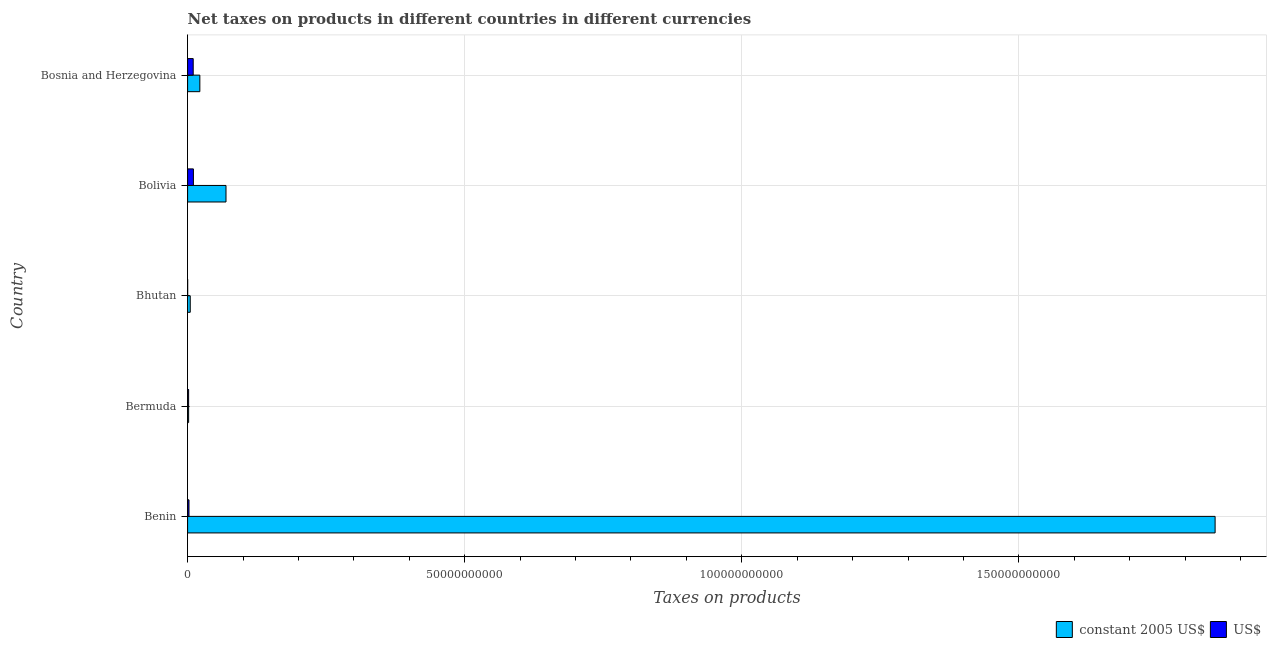Are the number of bars per tick equal to the number of legend labels?
Keep it short and to the point. Yes. Are the number of bars on each tick of the Y-axis equal?
Keep it short and to the point. Yes. How many bars are there on the 1st tick from the top?
Give a very brief answer. 2. What is the label of the 5th group of bars from the top?
Your response must be concise. Benin. In how many cases, is the number of bars for a given country not equal to the number of legend labels?
Keep it short and to the point. 0. What is the net taxes in us$ in Bhutan?
Offer a very short reply. 1.02e+07. Across all countries, what is the maximum net taxes in us$?
Offer a terse response. 1.05e+09. Across all countries, what is the minimum net taxes in constant 2005 us$?
Your answer should be compact. 1.85e+08. In which country was the net taxes in constant 2005 us$ minimum?
Provide a short and direct response. Bermuda. What is the total net taxes in us$ in the graph?
Offer a very short reply. 2.51e+09. What is the difference between the net taxes in constant 2005 us$ in Benin and that in Bhutan?
Make the answer very short. 1.85e+11. What is the difference between the net taxes in us$ in Bhutan and the net taxes in constant 2005 us$ in Bolivia?
Ensure brevity in your answer.  -6.92e+09. What is the average net taxes in us$ per country?
Provide a short and direct response. 5.02e+08. What is the difference between the net taxes in constant 2005 us$ and net taxes in us$ in Bermuda?
Provide a succinct answer. 0. In how many countries, is the net taxes in constant 2005 us$ greater than 150000000000 units?
Keep it short and to the point. 1. What is the ratio of the net taxes in us$ in Benin to that in Bermuda?
Your answer should be compact. 1.37. Is the difference between the net taxes in us$ in Bolivia and Bosnia and Herzegovina greater than the difference between the net taxes in constant 2005 us$ in Bolivia and Bosnia and Herzegovina?
Give a very brief answer. No. What is the difference between the highest and the second highest net taxes in constant 2005 us$?
Your response must be concise. 1.78e+11. What is the difference between the highest and the lowest net taxes in constant 2005 us$?
Provide a short and direct response. 1.85e+11. In how many countries, is the net taxes in us$ greater than the average net taxes in us$ taken over all countries?
Your answer should be compact. 2. What does the 1st bar from the top in Bolivia represents?
Your answer should be very brief. US$. What does the 1st bar from the bottom in Benin represents?
Ensure brevity in your answer.  Constant 2005 us$. How many bars are there?
Your answer should be compact. 10. Are the values on the major ticks of X-axis written in scientific E-notation?
Give a very brief answer. No. Does the graph contain grids?
Ensure brevity in your answer.  Yes. Where does the legend appear in the graph?
Your answer should be compact. Bottom right. What is the title of the graph?
Keep it short and to the point. Net taxes on products in different countries in different currencies. Does "Long-term debt" appear as one of the legend labels in the graph?
Offer a terse response. No. What is the label or title of the X-axis?
Offer a terse response. Taxes on products. What is the Taxes on products of constant 2005 US$ in Benin?
Offer a very short reply. 1.85e+11. What is the Taxes on products in US$ in Benin?
Ensure brevity in your answer.  2.53e+08. What is the Taxes on products of constant 2005 US$ in Bermuda?
Provide a succinct answer. 1.85e+08. What is the Taxes on products in US$ in Bermuda?
Keep it short and to the point. 1.85e+08. What is the Taxes on products in constant 2005 US$ in Bhutan?
Provide a short and direct response. 4.80e+08. What is the Taxes on products in US$ in Bhutan?
Provide a succinct answer. 1.02e+07. What is the Taxes on products in constant 2005 US$ in Bolivia?
Keep it short and to the point. 6.93e+09. What is the Taxes on products of US$ in Bolivia?
Your answer should be very brief. 1.05e+09. What is the Taxes on products of constant 2005 US$ in Bosnia and Herzegovina?
Your answer should be very brief. 2.21e+09. What is the Taxes on products of US$ in Bosnia and Herzegovina?
Your answer should be compact. 1.01e+09. Across all countries, what is the maximum Taxes on products in constant 2005 US$?
Ensure brevity in your answer.  1.85e+11. Across all countries, what is the maximum Taxes on products in US$?
Provide a short and direct response. 1.05e+09. Across all countries, what is the minimum Taxes on products of constant 2005 US$?
Offer a terse response. 1.85e+08. Across all countries, what is the minimum Taxes on products in US$?
Provide a short and direct response. 1.02e+07. What is the total Taxes on products of constant 2005 US$ in the graph?
Make the answer very short. 1.95e+11. What is the total Taxes on products of US$ in the graph?
Provide a succinct answer. 2.51e+09. What is the difference between the Taxes on products in constant 2005 US$ in Benin and that in Bermuda?
Give a very brief answer. 1.85e+11. What is the difference between the Taxes on products in US$ in Benin and that in Bermuda?
Make the answer very short. 6.83e+07. What is the difference between the Taxes on products of constant 2005 US$ in Benin and that in Bhutan?
Give a very brief answer. 1.85e+11. What is the difference between the Taxes on products in US$ in Benin and that in Bhutan?
Keep it short and to the point. 2.43e+08. What is the difference between the Taxes on products of constant 2005 US$ in Benin and that in Bolivia?
Your answer should be very brief. 1.78e+11. What is the difference between the Taxes on products of US$ in Benin and that in Bolivia?
Make the answer very short. -7.96e+08. What is the difference between the Taxes on products in constant 2005 US$ in Benin and that in Bosnia and Herzegovina?
Your answer should be very brief. 1.83e+11. What is the difference between the Taxes on products in US$ in Benin and that in Bosnia and Herzegovina?
Offer a terse response. -7.59e+08. What is the difference between the Taxes on products in constant 2005 US$ in Bermuda and that in Bhutan?
Ensure brevity in your answer.  -2.96e+08. What is the difference between the Taxes on products of US$ in Bermuda and that in Bhutan?
Ensure brevity in your answer.  1.74e+08. What is the difference between the Taxes on products in constant 2005 US$ in Bermuda and that in Bolivia?
Provide a succinct answer. -6.74e+09. What is the difference between the Taxes on products in US$ in Bermuda and that in Bolivia?
Your answer should be very brief. -8.64e+08. What is the difference between the Taxes on products in constant 2005 US$ in Bermuda and that in Bosnia and Herzegovina?
Make the answer very short. -2.03e+09. What is the difference between the Taxes on products of US$ in Bermuda and that in Bosnia and Herzegovina?
Provide a succinct answer. -8.27e+08. What is the difference between the Taxes on products of constant 2005 US$ in Bhutan and that in Bolivia?
Offer a terse response. -6.45e+09. What is the difference between the Taxes on products of US$ in Bhutan and that in Bolivia?
Make the answer very short. -1.04e+09. What is the difference between the Taxes on products in constant 2005 US$ in Bhutan and that in Bosnia and Herzegovina?
Keep it short and to the point. -1.73e+09. What is the difference between the Taxes on products of US$ in Bhutan and that in Bosnia and Herzegovina?
Make the answer very short. -1.00e+09. What is the difference between the Taxes on products in constant 2005 US$ in Bolivia and that in Bosnia and Herzegovina?
Provide a short and direct response. 4.72e+09. What is the difference between the Taxes on products of US$ in Bolivia and that in Bosnia and Herzegovina?
Your response must be concise. 3.70e+07. What is the difference between the Taxes on products of constant 2005 US$ in Benin and the Taxes on products of US$ in Bermuda?
Offer a very short reply. 1.85e+11. What is the difference between the Taxes on products in constant 2005 US$ in Benin and the Taxes on products in US$ in Bhutan?
Keep it short and to the point. 1.85e+11. What is the difference between the Taxes on products in constant 2005 US$ in Benin and the Taxes on products in US$ in Bolivia?
Offer a very short reply. 1.84e+11. What is the difference between the Taxes on products in constant 2005 US$ in Benin and the Taxes on products in US$ in Bosnia and Herzegovina?
Make the answer very short. 1.84e+11. What is the difference between the Taxes on products in constant 2005 US$ in Bermuda and the Taxes on products in US$ in Bhutan?
Provide a short and direct response. 1.74e+08. What is the difference between the Taxes on products of constant 2005 US$ in Bermuda and the Taxes on products of US$ in Bolivia?
Your answer should be compact. -8.64e+08. What is the difference between the Taxes on products in constant 2005 US$ in Bermuda and the Taxes on products in US$ in Bosnia and Herzegovina?
Offer a terse response. -8.27e+08. What is the difference between the Taxes on products of constant 2005 US$ in Bhutan and the Taxes on products of US$ in Bolivia?
Provide a succinct answer. -5.68e+08. What is the difference between the Taxes on products of constant 2005 US$ in Bhutan and the Taxes on products of US$ in Bosnia and Herzegovina?
Keep it short and to the point. -5.31e+08. What is the difference between the Taxes on products of constant 2005 US$ in Bolivia and the Taxes on products of US$ in Bosnia and Herzegovina?
Offer a very short reply. 5.92e+09. What is the average Taxes on products of constant 2005 US$ per country?
Make the answer very short. 3.90e+1. What is the average Taxes on products of US$ per country?
Make the answer very short. 5.02e+08. What is the difference between the Taxes on products in constant 2005 US$ and Taxes on products in US$ in Benin?
Your answer should be compact. 1.85e+11. What is the difference between the Taxes on products in constant 2005 US$ and Taxes on products in US$ in Bermuda?
Provide a short and direct response. 0. What is the difference between the Taxes on products of constant 2005 US$ and Taxes on products of US$ in Bhutan?
Offer a very short reply. 4.70e+08. What is the difference between the Taxes on products of constant 2005 US$ and Taxes on products of US$ in Bolivia?
Offer a terse response. 5.88e+09. What is the difference between the Taxes on products in constant 2005 US$ and Taxes on products in US$ in Bosnia and Herzegovina?
Ensure brevity in your answer.  1.20e+09. What is the ratio of the Taxes on products in constant 2005 US$ in Benin to that in Bermuda?
Offer a terse response. 1004.24. What is the ratio of the Taxes on products of US$ in Benin to that in Bermuda?
Ensure brevity in your answer.  1.37. What is the ratio of the Taxes on products in constant 2005 US$ in Benin to that in Bhutan?
Your response must be concise. 386.06. What is the ratio of the Taxes on products of US$ in Benin to that in Bhutan?
Keep it short and to the point. 24.85. What is the ratio of the Taxes on products of constant 2005 US$ in Benin to that in Bolivia?
Your answer should be compact. 26.76. What is the ratio of the Taxes on products in US$ in Benin to that in Bolivia?
Ensure brevity in your answer.  0.24. What is the ratio of the Taxes on products in constant 2005 US$ in Benin to that in Bosnia and Herzegovina?
Your answer should be very brief. 83.85. What is the ratio of the Taxes on products in constant 2005 US$ in Bermuda to that in Bhutan?
Ensure brevity in your answer.  0.38. What is the ratio of the Taxes on products in US$ in Bermuda to that in Bhutan?
Provide a succinct answer. 18.14. What is the ratio of the Taxes on products of constant 2005 US$ in Bermuda to that in Bolivia?
Your answer should be very brief. 0.03. What is the ratio of the Taxes on products of US$ in Bermuda to that in Bolivia?
Your answer should be compact. 0.18. What is the ratio of the Taxes on products in constant 2005 US$ in Bermuda to that in Bosnia and Herzegovina?
Offer a terse response. 0.08. What is the ratio of the Taxes on products of US$ in Bermuda to that in Bosnia and Herzegovina?
Offer a very short reply. 0.18. What is the ratio of the Taxes on products of constant 2005 US$ in Bhutan to that in Bolivia?
Your answer should be compact. 0.07. What is the ratio of the Taxes on products in US$ in Bhutan to that in Bolivia?
Give a very brief answer. 0.01. What is the ratio of the Taxes on products of constant 2005 US$ in Bhutan to that in Bosnia and Herzegovina?
Provide a succinct answer. 0.22. What is the ratio of the Taxes on products of US$ in Bhutan to that in Bosnia and Herzegovina?
Your answer should be very brief. 0.01. What is the ratio of the Taxes on products of constant 2005 US$ in Bolivia to that in Bosnia and Herzegovina?
Offer a terse response. 3.13. What is the ratio of the Taxes on products of US$ in Bolivia to that in Bosnia and Herzegovina?
Your answer should be very brief. 1.04. What is the difference between the highest and the second highest Taxes on products of constant 2005 US$?
Make the answer very short. 1.78e+11. What is the difference between the highest and the second highest Taxes on products in US$?
Your answer should be compact. 3.70e+07. What is the difference between the highest and the lowest Taxes on products in constant 2005 US$?
Your answer should be very brief. 1.85e+11. What is the difference between the highest and the lowest Taxes on products in US$?
Provide a succinct answer. 1.04e+09. 